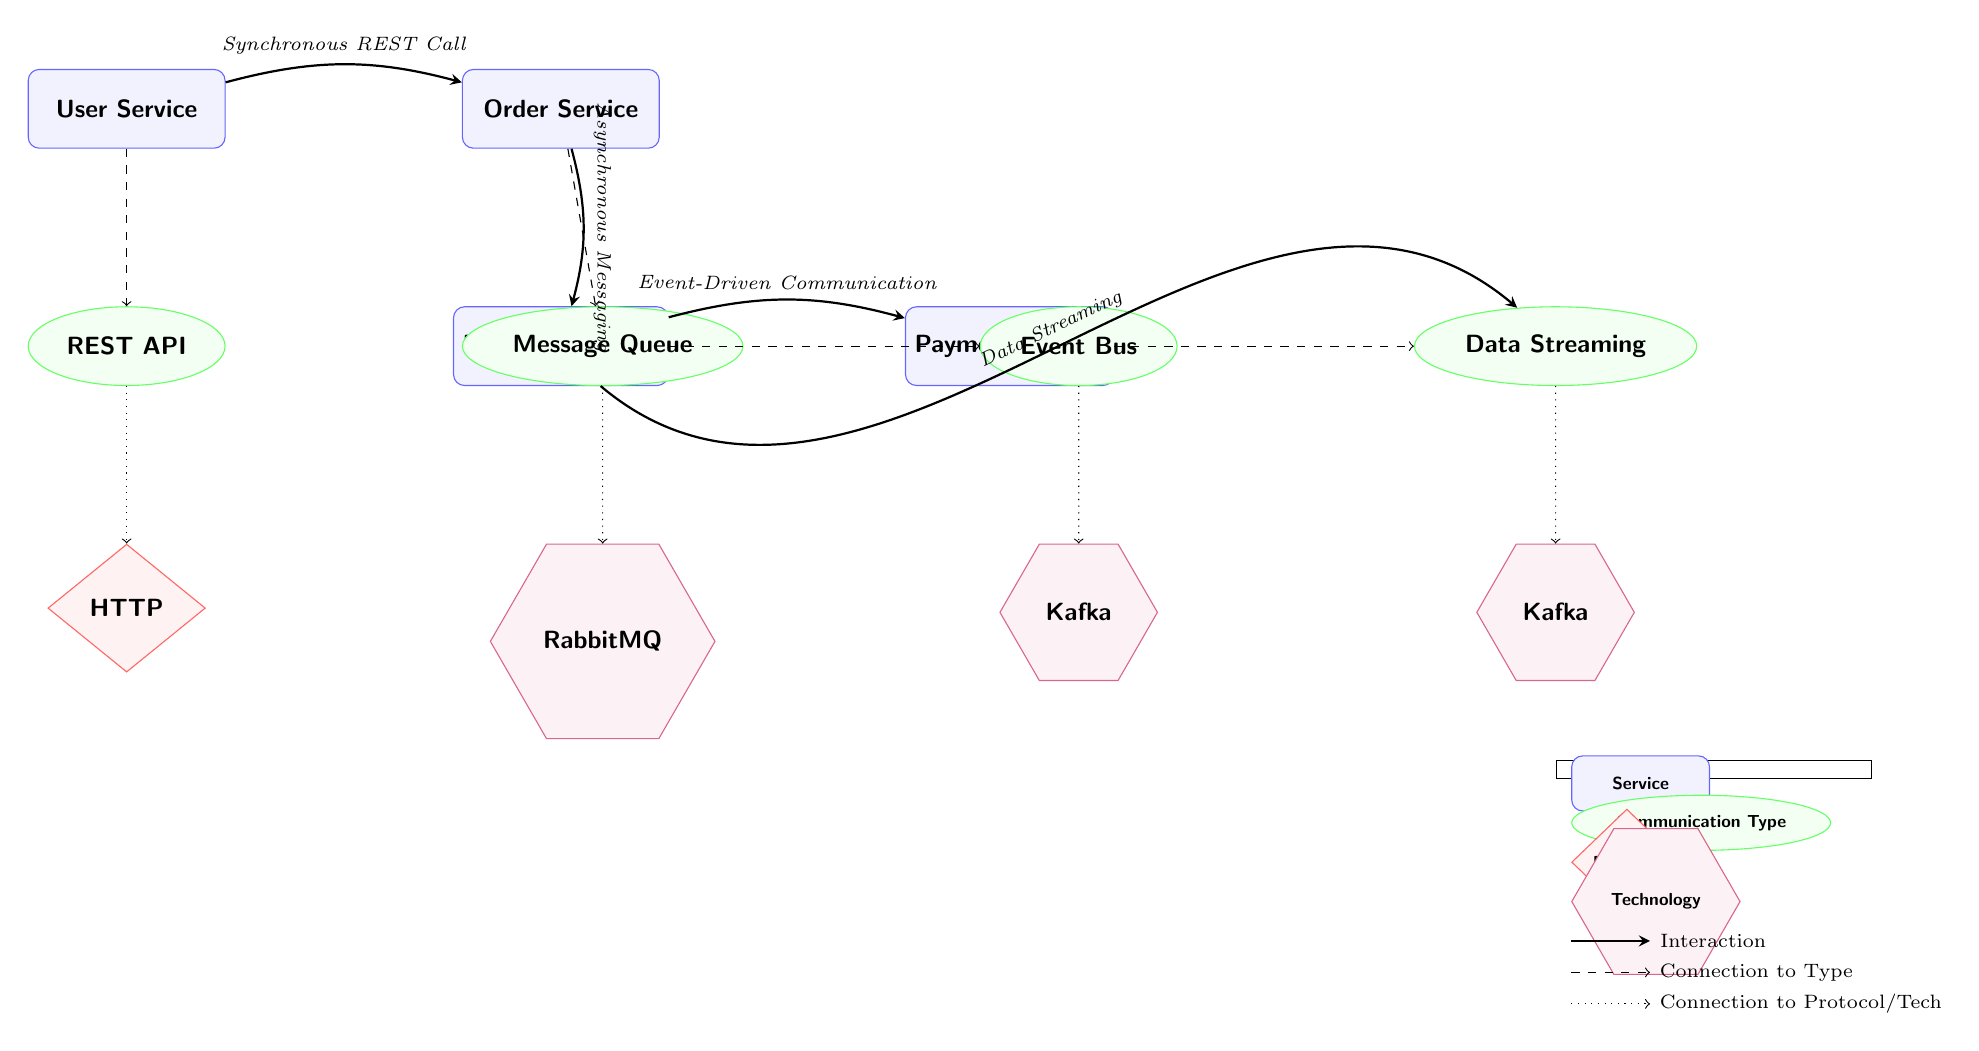What is the name of the service that interacts directly with the User Service? The diagram shows a direct interaction line from the User Service to the Order Service, indicating that the Order Service is the one that communicates with the User Service.
Answer: Order Service How many communication types are shown in the diagram? The diagram contains four communication types: REST API, Message Queue, Event Bus, and Data Streaming. Counting these communication types gives us a total of four.
Answer: 4 What type of communication is used between the Order Service and the Inventory Service? The interaction line between the Order Service and the Inventory Service notes "Asynchronous Messaging," indicating that this is the method of communication used between these two services.
Answer: Asynchronous Messaging Which service employs Event-Driven Communication? The diagram indicates an interaction from the Inventory Service to the Payment Service labeled "Event-Driven Communication," which means the Payment Service uses this communication method.
Answer: Payment Service What protocol is associated with the REST API communication type? Under the communication type REST API, there is a dotted line leading to the HTTP protocol, which signifies that HTTP is the protocol used for REST API communications in this diagram.
Answer: HTTP Which technology is connected to the Message Queue communication type? Below the Message Queue box, there is a direct dotted line leading to RabbitMQ, indicating that RabbitMQ is the technology used for this type of communication.
Answer: RabbitMQ How is Data Streaming represented in relation to services? The diagram shows an interaction from the Inventory Service to the Data Streaming box, labeled "Data Streaming," indicating that Data Streaming is employed in context of service communication.
Answer: Data Streaming Which service does the Data Streaming communication type connect to? The interaction from the Inventory Service leads to the Data Streaming communication type, indicating that this type of communication is linked with the Streaming service shown on the diagram.
Answer: Streaming Which communication type is characterized by a Synchronous REST call? The interaction between the User Service and the Order Service is labeled "Synchronous REST Call," making Synchronous REST Call the correct communication type in this context.
Answer: Synchronous REST Call 